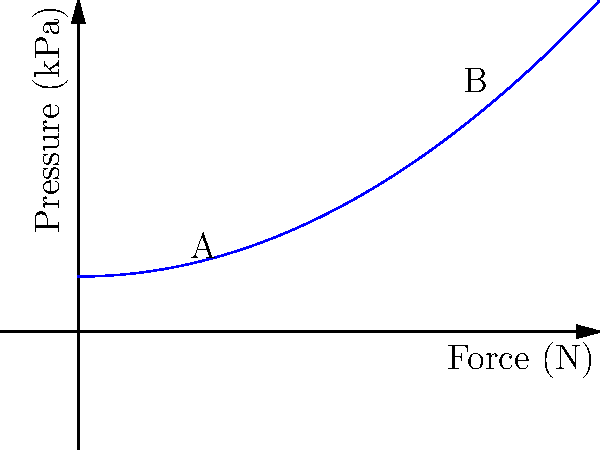The graph shows the relationship between force and pressure during a common physical therapy exercise for a chronic condition. If the exercise starts at point A and ends at point B, what is the change in pressure (in kPa) experienced during this exercise? To solve this problem, we need to follow these steps:

1. Identify the pressure values at points A and B:
   - Point A: $(2, f(2)) = (2, 0.5 \cdot 2^2 + 10) = (2, 12)$
   - Point B: $(8, f(8)) = (8, 0.5 \cdot 8^2 + 10) = (8, 42)$

2. Calculate the change in pressure:
   $\Delta P = P_B - P_A$
   $\Delta P = 42 \text{ kPa} - 12 \text{ kPa} = 30 \text{ kPa}$

Therefore, the change in pressure experienced during this exercise is 30 kPa.
Answer: 30 kPa 